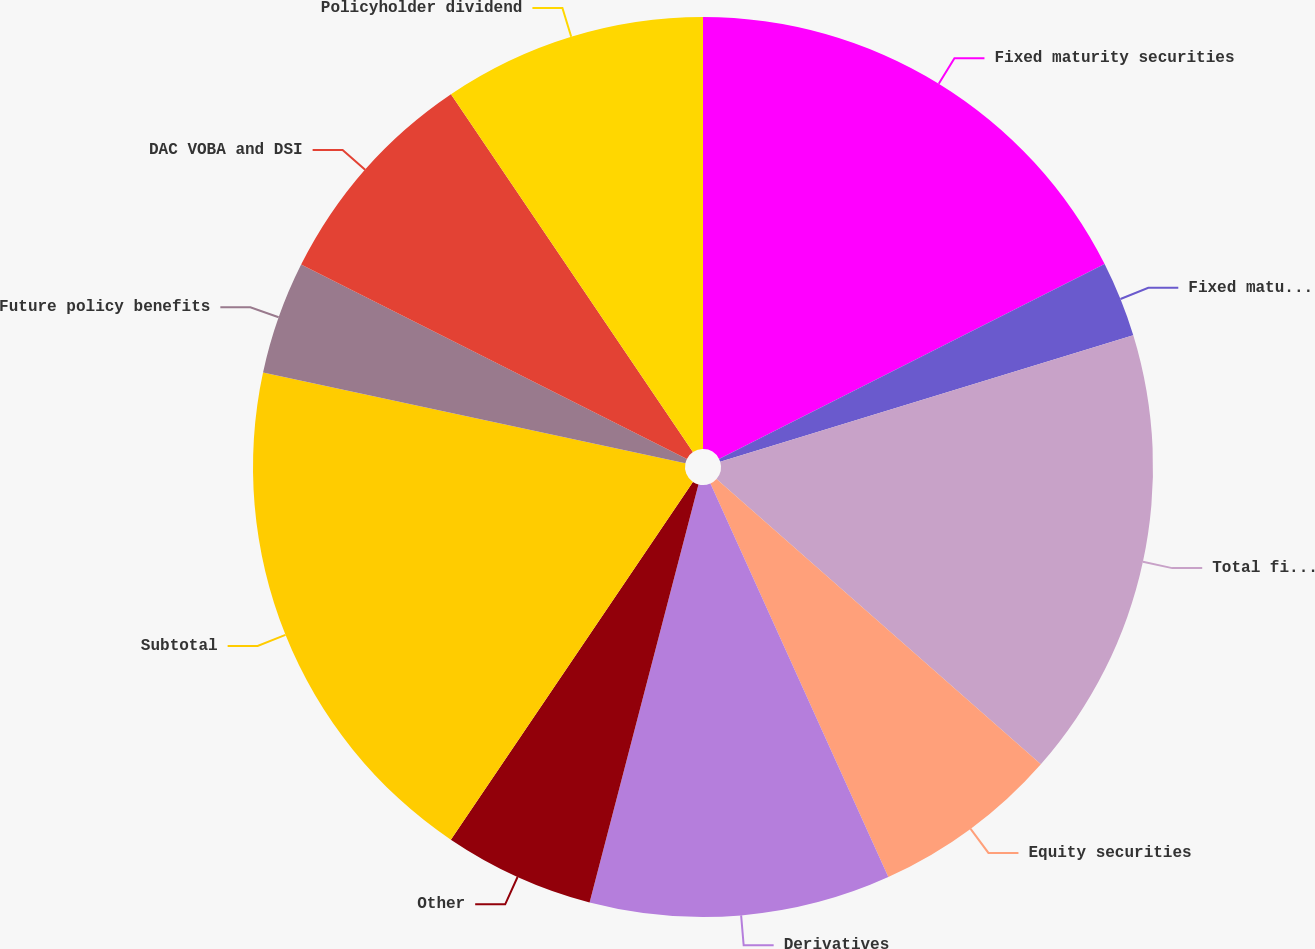Convert chart. <chart><loc_0><loc_0><loc_500><loc_500><pie_chart><fcel>Fixed maturity securities<fcel>Fixed maturity securities with<fcel>Total fixed maturity<fcel>Equity securities<fcel>Derivatives<fcel>Other<fcel>Subtotal<fcel>Future policy benefits<fcel>DAC VOBA and DSI<fcel>Policyholder dividend<nl><fcel>17.55%<fcel>2.72%<fcel>16.21%<fcel>6.76%<fcel>10.81%<fcel>5.41%<fcel>18.9%<fcel>4.06%<fcel>8.11%<fcel>9.46%<nl></chart> 